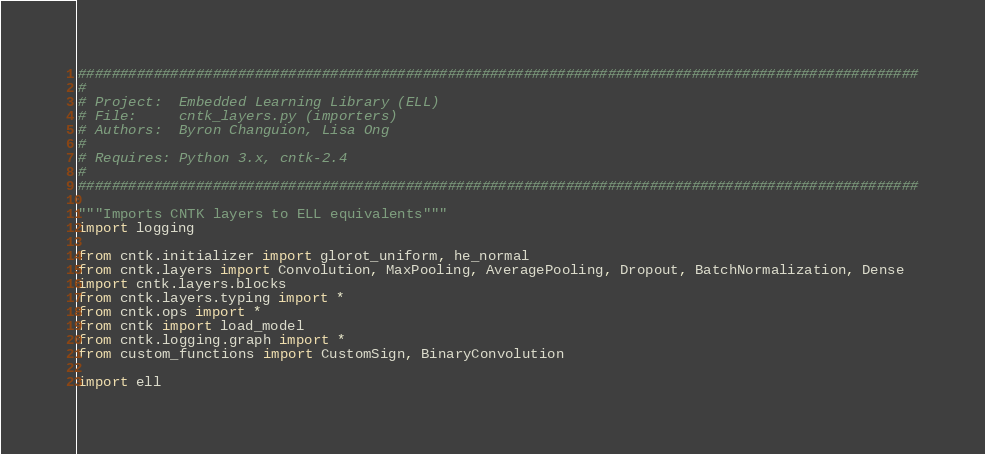<code> <loc_0><loc_0><loc_500><loc_500><_Python_>####################################################################################################
#
# Project:  Embedded Learning Library (ELL)
# File:     cntk_layers.py (importers)
# Authors:  Byron Changuion, Lisa Ong
#
# Requires: Python 3.x, cntk-2.4
#
####################################################################################################

"""Imports CNTK layers to ELL equivalents"""
import logging

from cntk.initializer import glorot_uniform, he_normal
from cntk.layers import Convolution, MaxPooling, AveragePooling, Dropout, BatchNormalization, Dense
import cntk.layers.blocks
from cntk.layers.typing import *
from cntk.ops import *
from cntk import load_model
from cntk.logging.graph import *
from custom_functions import CustomSign, BinaryConvolution

import ell</code> 